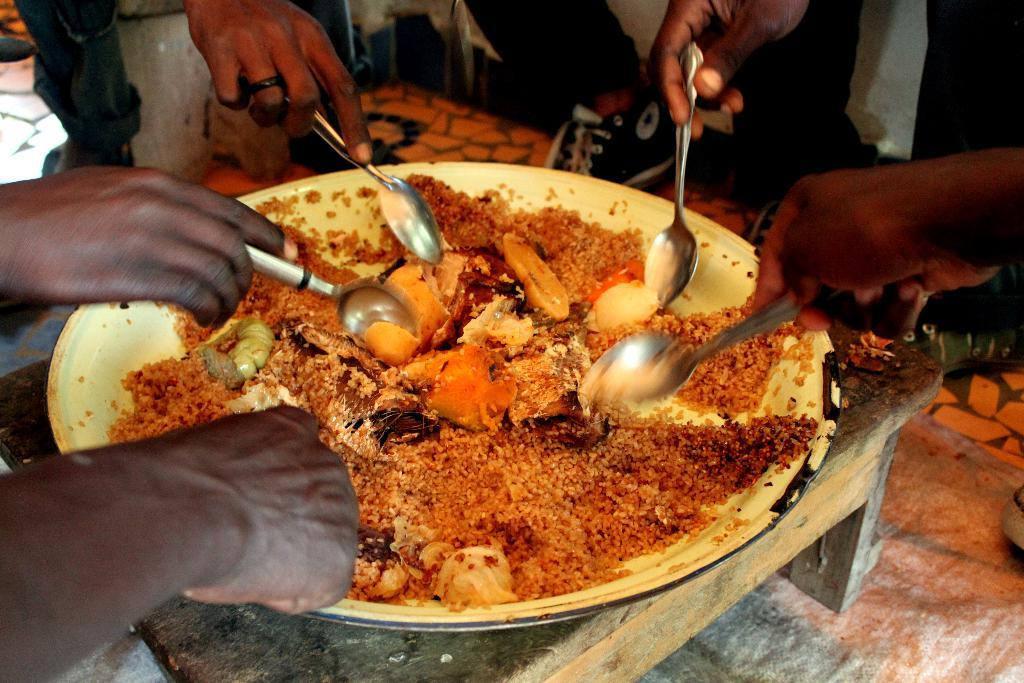What colors are the food items in the image? The food in the image has brown and orange colors. How is the food arranged in the image? The food is on a plate in the image. What color is the plate? The plate is white. What is being used to eat the food in the image? Human hands are holding spoons in the image. What type of net can be seen in the image? There is no net present in the image. How many people are participating in the feast in the image? The image does not depict a feast, so it is not possible to determine the number of participants. 